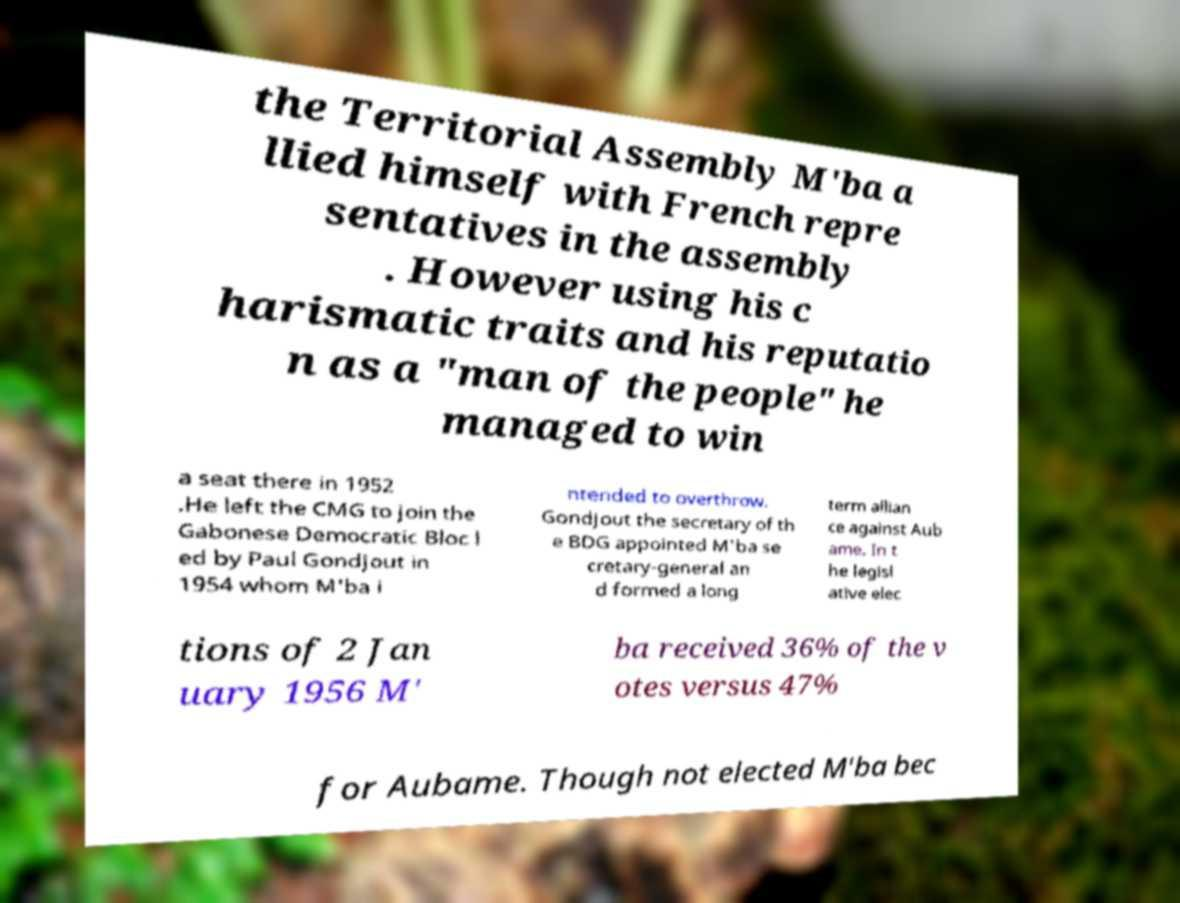Can you read and provide the text displayed in the image?This photo seems to have some interesting text. Can you extract and type it out for me? the Territorial Assembly M'ba a llied himself with French repre sentatives in the assembly . However using his c harismatic traits and his reputatio n as a "man of the people" he managed to win a seat there in 1952 .He left the CMG to join the Gabonese Democratic Bloc l ed by Paul Gondjout in 1954 whom M'ba i ntended to overthrow. Gondjout the secretary of th e BDG appointed M'ba se cretary-general an d formed a long term allian ce against Aub ame. In t he legisl ative elec tions of 2 Jan uary 1956 M' ba received 36% of the v otes versus 47% for Aubame. Though not elected M'ba bec 